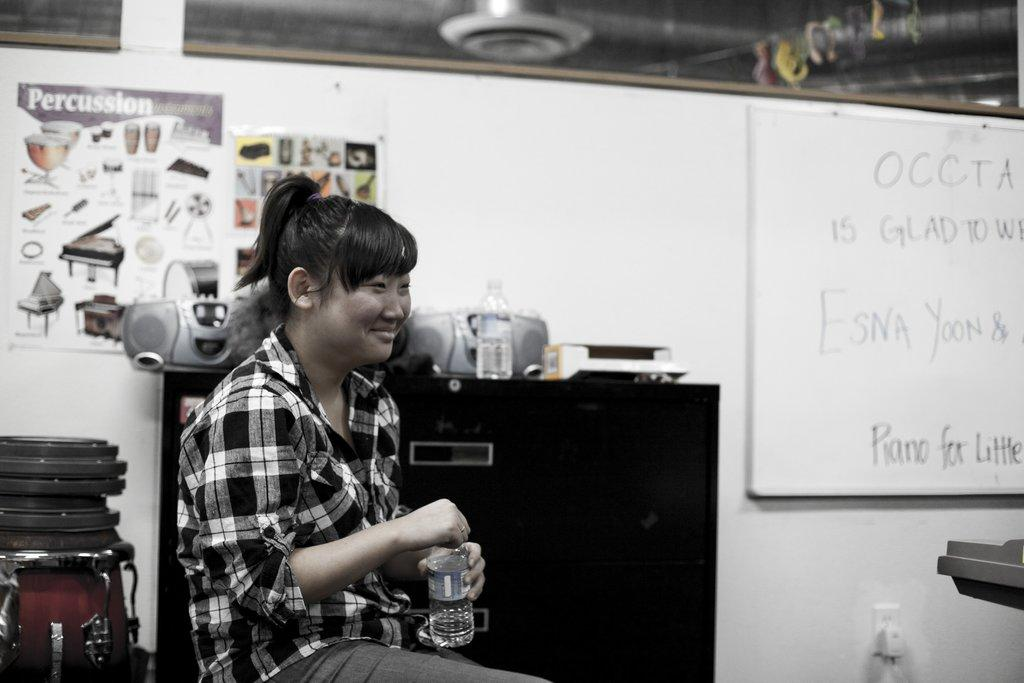<image>
Offer a succinct explanation of the picture presented. Woman sitting in a classroom with a poster titled Percussion behind her. 